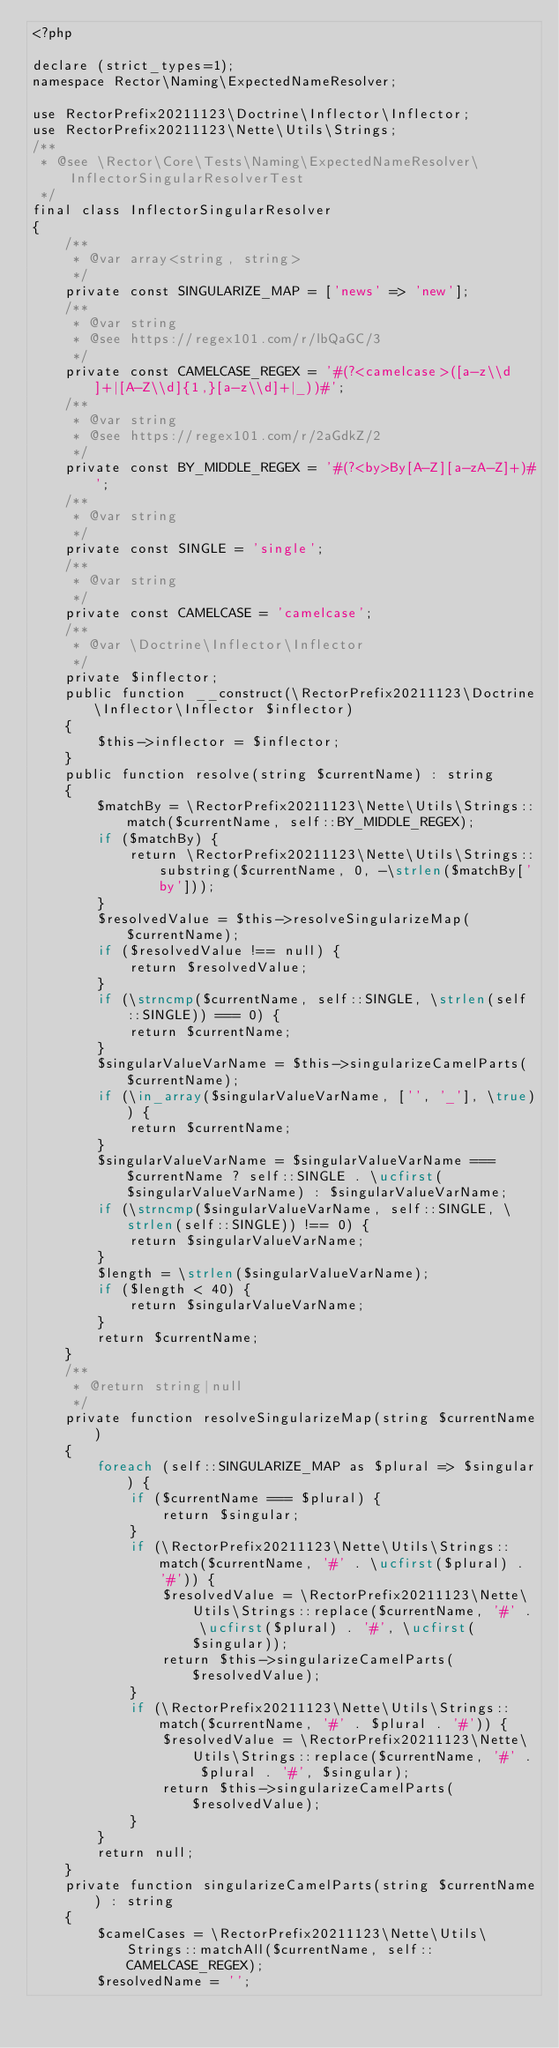<code> <loc_0><loc_0><loc_500><loc_500><_PHP_><?php

declare (strict_types=1);
namespace Rector\Naming\ExpectedNameResolver;

use RectorPrefix20211123\Doctrine\Inflector\Inflector;
use RectorPrefix20211123\Nette\Utils\Strings;
/**
 * @see \Rector\Core\Tests\Naming\ExpectedNameResolver\InflectorSingularResolverTest
 */
final class InflectorSingularResolver
{
    /**
     * @var array<string, string>
     */
    private const SINGULARIZE_MAP = ['news' => 'new'];
    /**
     * @var string
     * @see https://regex101.com/r/lbQaGC/3
     */
    private const CAMELCASE_REGEX = '#(?<camelcase>([a-z\\d]+|[A-Z\\d]{1,}[a-z\\d]+|_))#';
    /**
     * @var string
     * @see https://regex101.com/r/2aGdkZ/2
     */
    private const BY_MIDDLE_REGEX = '#(?<by>By[A-Z][a-zA-Z]+)#';
    /**
     * @var string
     */
    private const SINGLE = 'single';
    /**
     * @var string
     */
    private const CAMELCASE = 'camelcase';
    /**
     * @var \Doctrine\Inflector\Inflector
     */
    private $inflector;
    public function __construct(\RectorPrefix20211123\Doctrine\Inflector\Inflector $inflector)
    {
        $this->inflector = $inflector;
    }
    public function resolve(string $currentName) : string
    {
        $matchBy = \RectorPrefix20211123\Nette\Utils\Strings::match($currentName, self::BY_MIDDLE_REGEX);
        if ($matchBy) {
            return \RectorPrefix20211123\Nette\Utils\Strings::substring($currentName, 0, -\strlen($matchBy['by']));
        }
        $resolvedValue = $this->resolveSingularizeMap($currentName);
        if ($resolvedValue !== null) {
            return $resolvedValue;
        }
        if (\strncmp($currentName, self::SINGLE, \strlen(self::SINGLE)) === 0) {
            return $currentName;
        }
        $singularValueVarName = $this->singularizeCamelParts($currentName);
        if (\in_array($singularValueVarName, ['', '_'], \true)) {
            return $currentName;
        }
        $singularValueVarName = $singularValueVarName === $currentName ? self::SINGLE . \ucfirst($singularValueVarName) : $singularValueVarName;
        if (\strncmp($singularValueVarName, self::SINGLE, \strlen(self::SINGLE)) !== 0) {
            return $singularValueVarName;
        }
        $length = \strlen($singularValueVarName);
        if ($length < 40) {
            return $singularValueVarName;
        }
        return $currentName;
    }
    /**
     * @return string|null
     */
    private function resolveSingularizeMap(string $currentName)
    {
        foreach (self::SINGULARIZE_MAP as $plural => $singular) {
            if ($currentName === $plural) {
                return $singular;
            }
            if (\RectorPrefix20211123\Nette\Utils\Strings::match($currentName, '#' . \ucfirst($plural) . '#')) {
                $resolvedValue = \RectorPrefix20211123\Nette\Utils\Strings::replace($currentName, '#' . \ucfirst($plural) . '#', \ucfirst($singular));
                return $this->singularizeCamelParts($resolvedValue);
            }
            if (\RectorPrefix20211123\Nette\Utils\Strings::match($currentName, '#' . $plural . '#')) {
                $resolvedValue = \RectorPrefix20211123\Nette\Utils\Strings::replace($currentName, '#' . $plural . '#', $singular);
                return $this->singularizeCamelParts($resolvedValue);
            }
        }
        return null;
    }
    private function singularizeCamelParts(string $currentName) : string
    {
        $camelCases = \RectorPrefix20211123\Nette\Utils\Strings::matchAll($currentName, self::CAMELCASE_REGEX);
        $resolvedName = '';</code> 